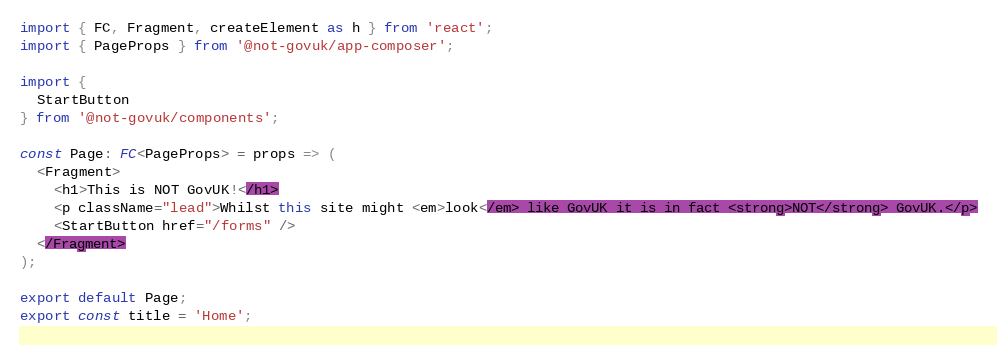<code> <loc_0><loc_0><loc_500><loc_500><_TypeScript_>import { FC, Fragment, createElement as h } from 'react';
import { PageProps } from '@not-govuk/app-composer';

import {
  StartButton
} from '@not-govuk/components';

const Page: FC<PageProps> = props => (
  <Fragment>
    <h1>This is NOT GovUK!</h1>
    <p className="lead">Whilst this site might <em>look</em> like GovUK it is in fact <strong>NOT</strong> GovUK.</p>
    <StartButton href="/forms" />
  </Fragment>
);

export default Page;
export const title = 'Home';
</code> 